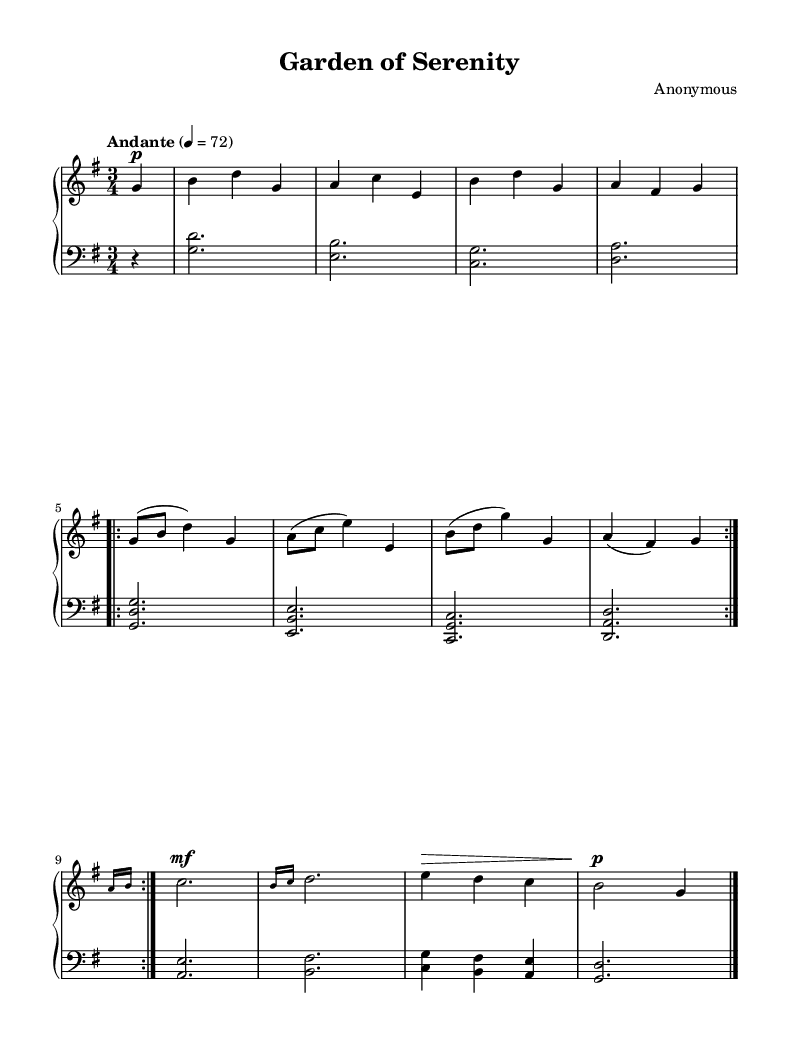What is the key signature of this music? The key signature is G major, indicated by one sharp (F#) at the beginning of the staff.
Answer: G major What is the time signature of this music? The time signature is 3/4, which indicates there are three beats per measure, with a quarter note receiving one beat.
Answer: 3/4 What is the tempo marking for this piece? The tempo marking is "Andante," which typically indicates a moderately slow pace.
Answer: Andante How many measures are repeated in this composition? The composition includes a repeat that encompasses four measures, denoted by the repeat signs.
Answer: Four measures What dynamics are indicated in the right-hand part for the opening notes? The right-hand part begins with the dynamic marking "p" (piano), meaning to play softly.
Answer: Piano What is the final dynamic marking for the last note played? The final dynamic marking at the end of the piece is "p" (piano), indicating it should finish softly.
Answer: Piano What type of musical piece does this represent? This piece is characterized as a romantic gentle composition, inspired by nature's beauty due to its serene melody and flowing rhythm.
Answer: Romantic 